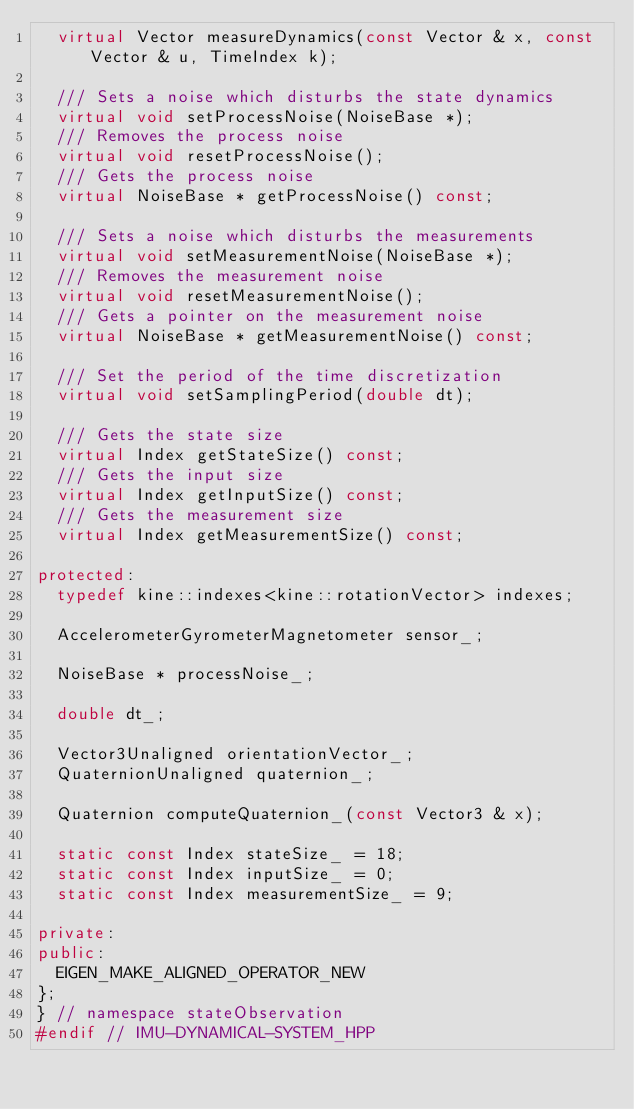Convert code to text. <code><loc_0><loc_0><loc_500><loc_500><_C++_>  virtual Vector measureDynamics(const Vector & x, const Vector & u, TimeIndex k);

  /// Sets a noise which disturbs the state dynamics
  virtual void setProcessNoise(NoiseBase *);
  /// Removes the process noise
  virtual void resetProcessNoise();
  /// Gets the process noise
  virtual NoiseBase * getProcessNoise() const;

  /// Sets a noise which disturbs the measurements
  virtual void setMeasurementNoise(NoiseBase *);
  /// Removes the measurement noise
  virtual void resetMeasurementNoise();
  /// Gets a pointer on the measurement noise
  virtual NoiseBase * getMeasurementNoise() const;

  /// Set the period of the time discretization
  virtual void setSamplingPeriod(double dt);

  /// Gets the state size
  virtual Index getStateSize() const;
  /// Gets the input size
  virtual Index getInputSize() const;
  /// Gets the measurement size
  virtual Index getMeasurementSize() const;

protected:
  typedef kine::indexes<kine::rotationVector> indexes;

  AccelerometerGyrometerMagnetometer sensor_;

  NoiseBase * processNoise_;

  double dt_;

  Vector3Unaligned orientationVector_;
  QuaternionUnaligned quaternion_;

  Quaternion computeQuaternion_(const Vector3 & x);

  static const Index stateSize_ = 18;
  static const Index inputSize_ = 0;
  static const Index measurementSize_ = 9;

private:
public:
  EIGEN_MAKE_ALIGNED_OPERATOR_NEW
};
} // namespace stateObservation
#endif // IMU-DYNAMICAL-SYSTEM_HPP
</code> 